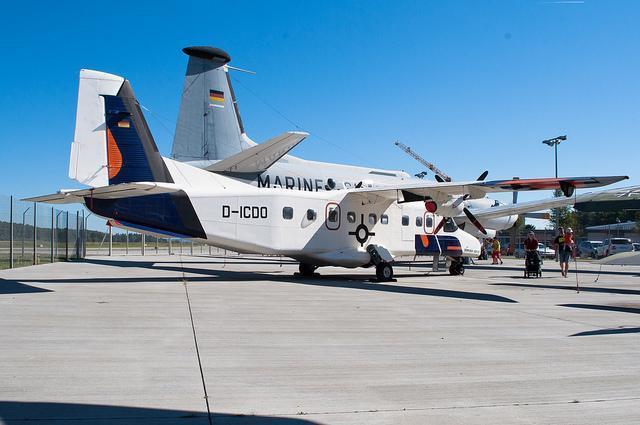How many planes do you see?
Give a very brief answer. 2. 